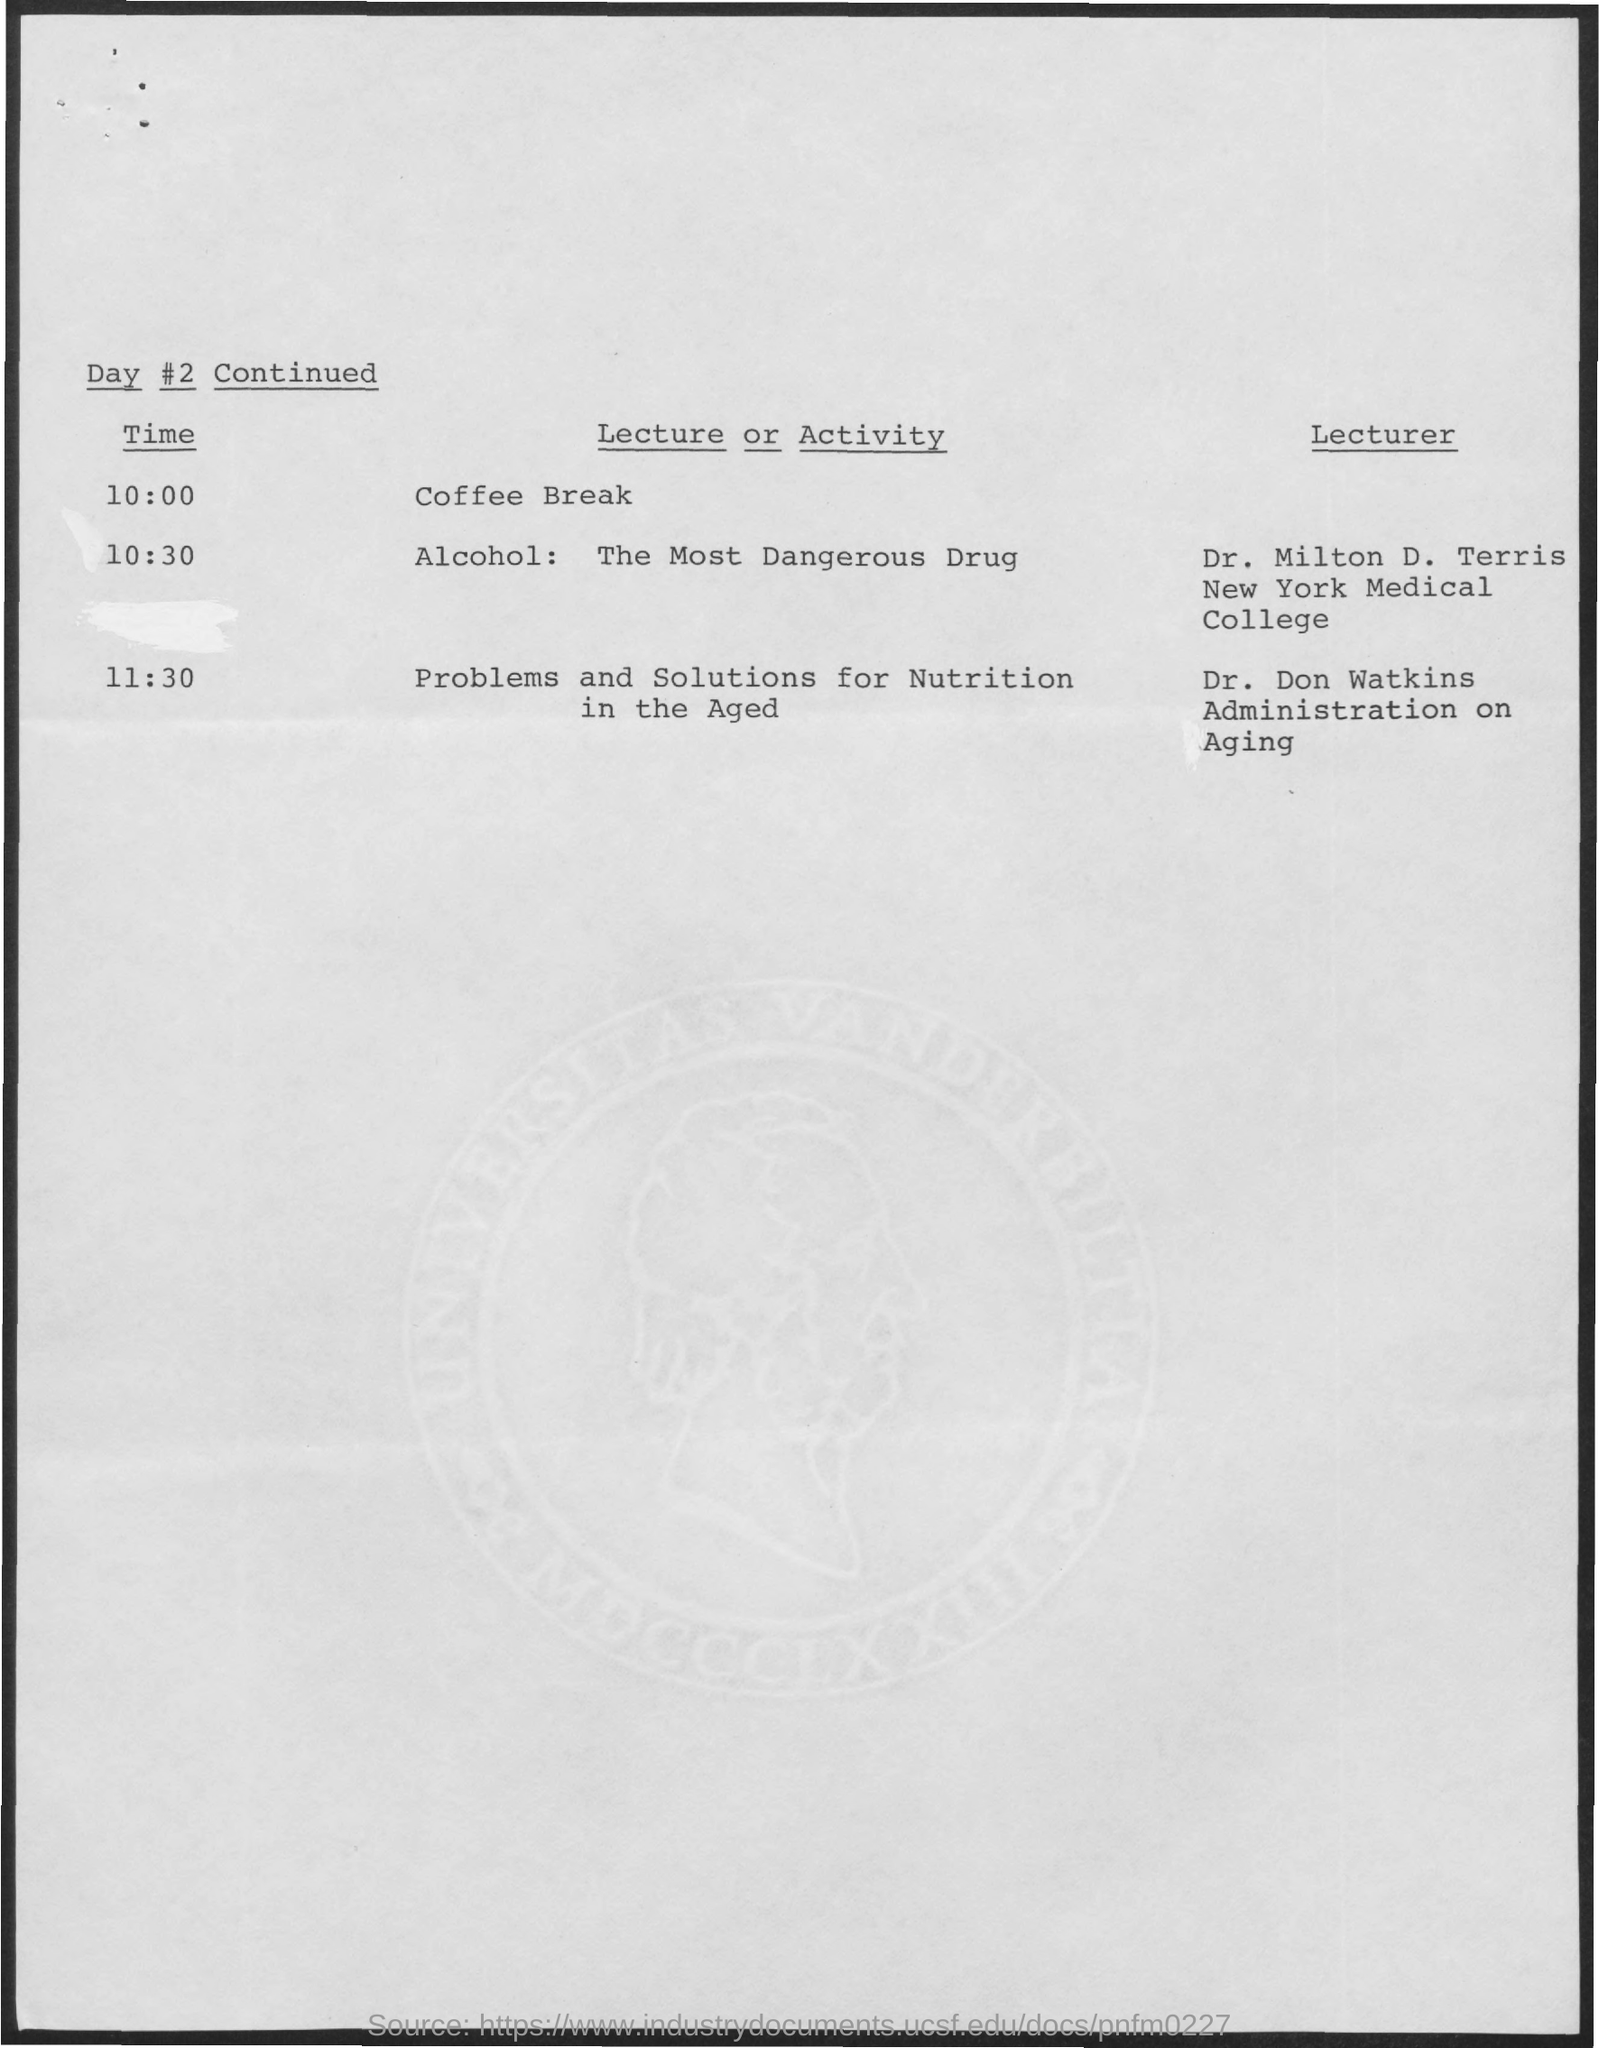What is the schedule at the time of 10:00 ?
Ensure brevity in your answer.  Coffee Break. What is the name of the activity at the time of 10:30 as mentioned ?
Offer a very short reply. Alcohol : The Most Dangerous Drug. What is the name of the activity at the time of 11:30 as mentioned ?
Your answer should be very brief. Problems and solutions for nutrition in the aged. What is the name of the lecturer mentioned at the time of 10:30 ?
Offer a very short reply. Dr. Milton D. Terris. What is the name of the lecturer mentioned at the time of 11:30 ?
Your response must be concise. Dr. Don Watkins. 